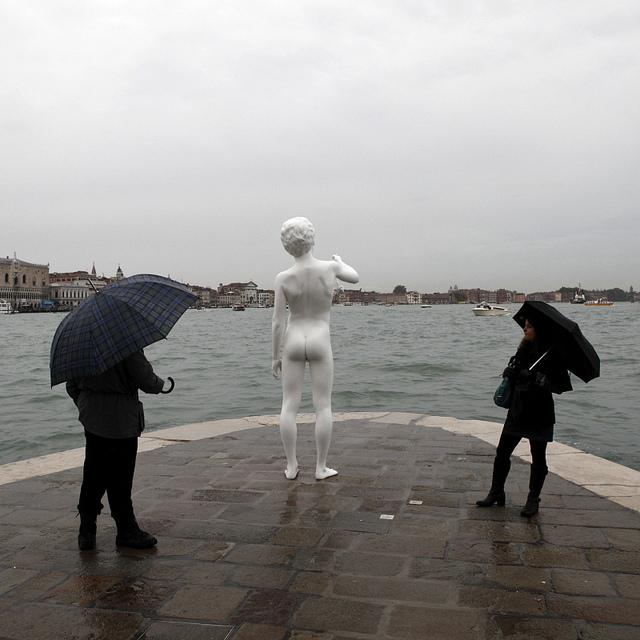How many people are there?
Be succinct. 2. What are the people holding?
Keep it brief. Umbrellas. Is it a sunny day?
Keep it brief. No. What color is the statue?
Quick response, please. White. Where is the statue?
Keep it brief. In middle. 